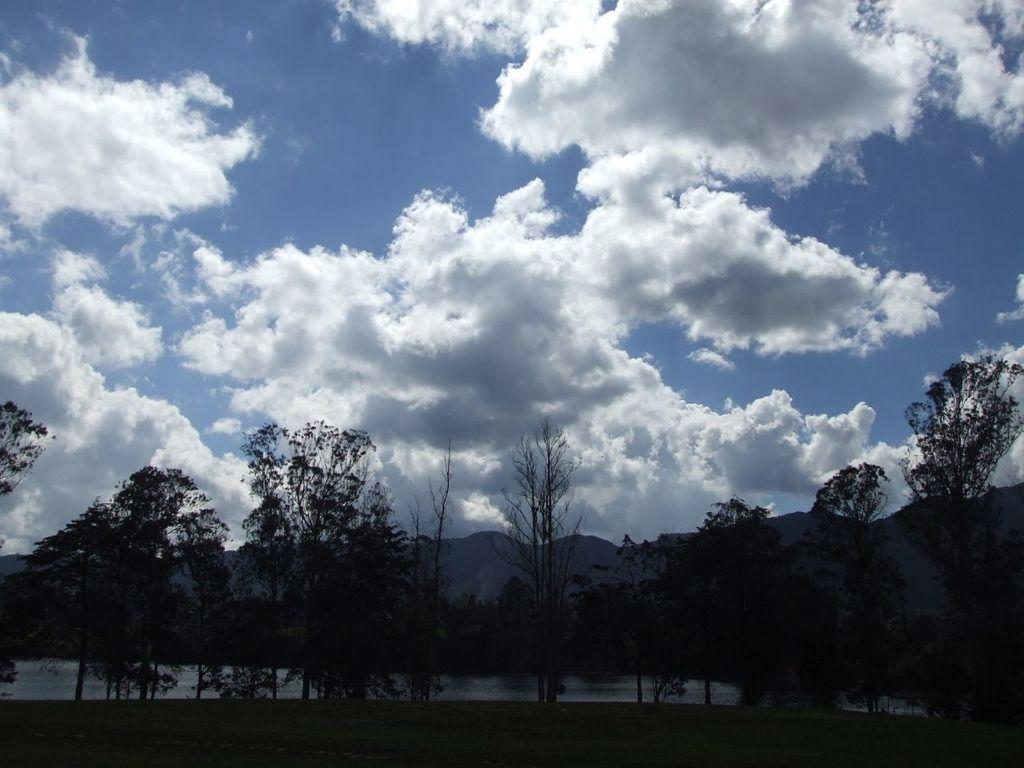What type of landscape is depicted in the image? There is an open grass area in the image. What can be seen in the front of the image? There are trees in the front of the image. What is visible in the background of the image? Water, mountains, clouds, and the sky are visible in the background of the image. What type of religious symbol can be seen in the image? There is no religious symbol present in the image. Can you see any ghosts in the image? There are no ghosts present in the image. 